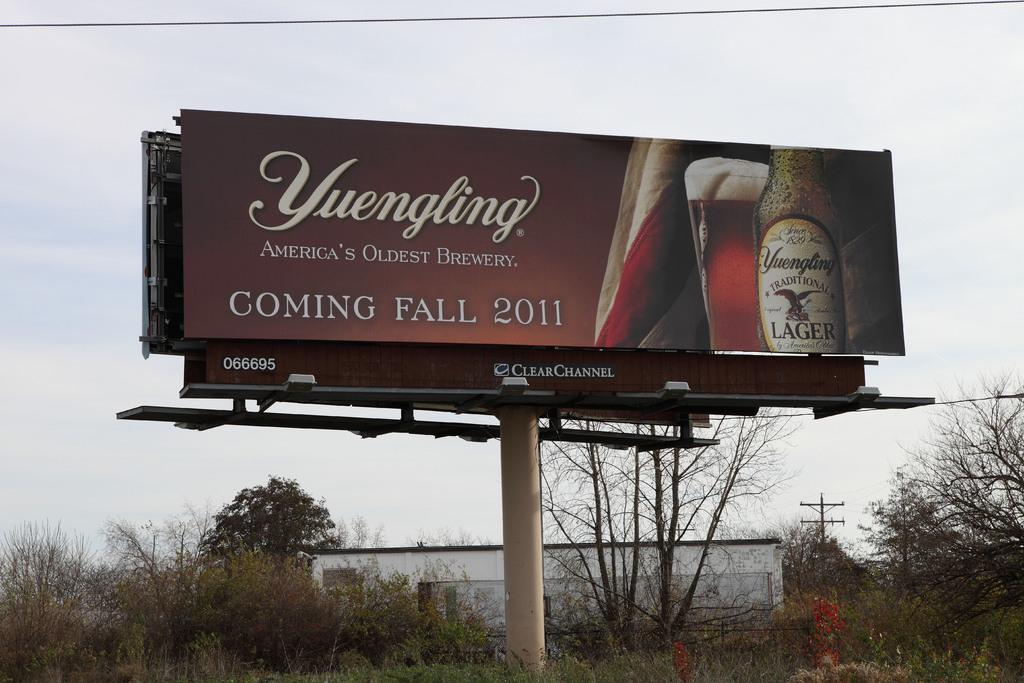Provide a one-sentence caption for the provided image. a large Yuengling beer sign says it is coming Fall 2011. 